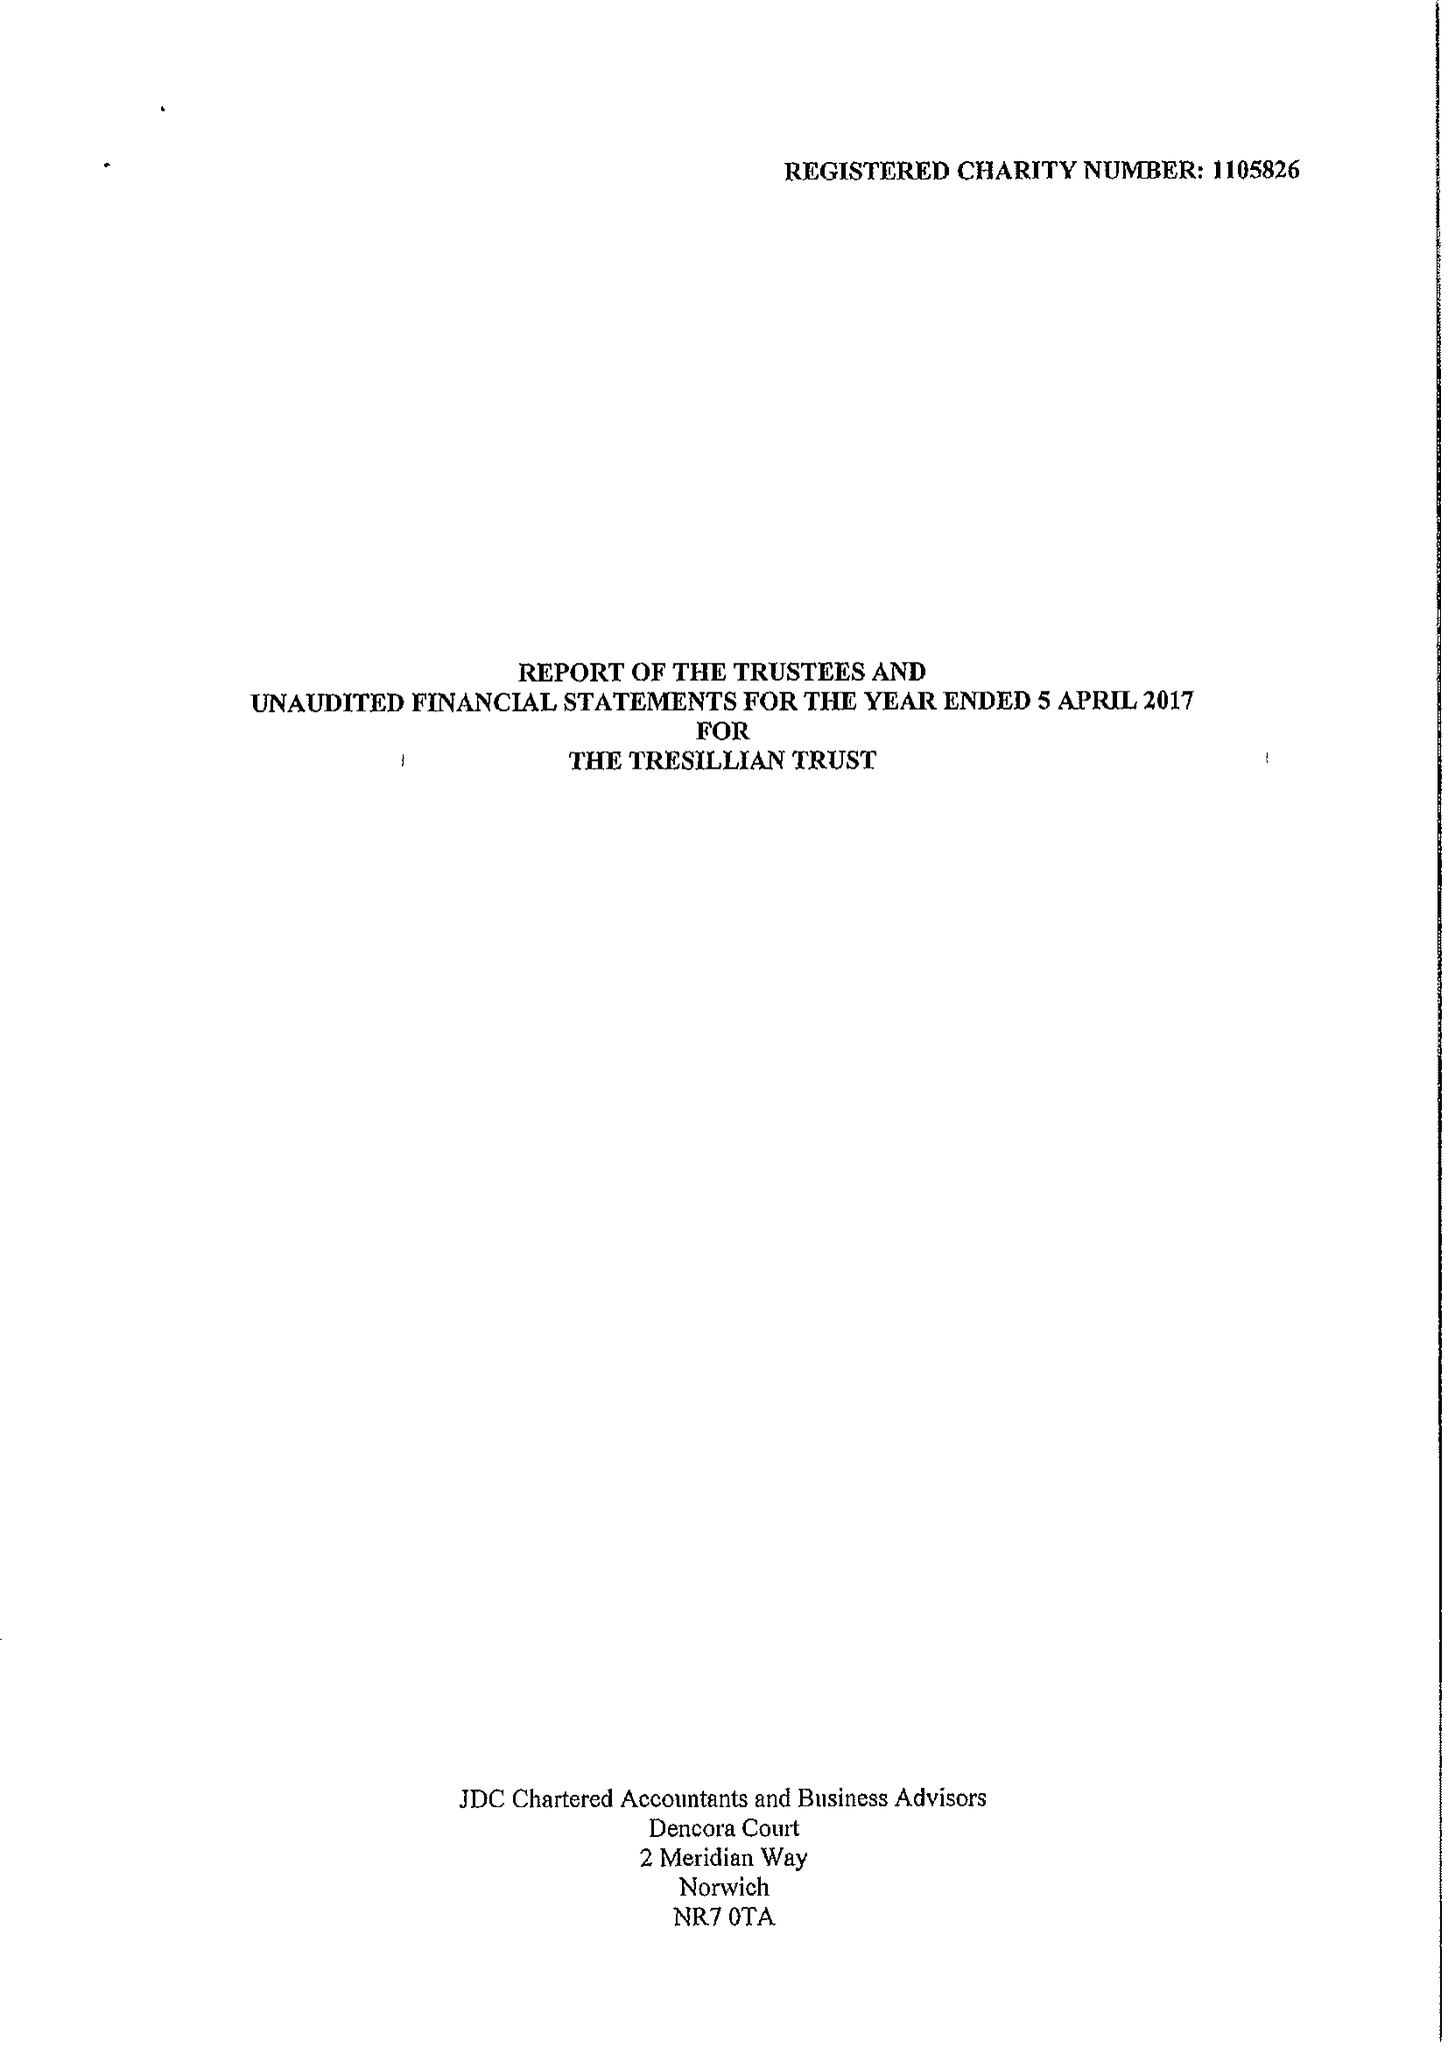What is the value for the report_date?
Answer the question using a single word or phrase. 2017-04-05 